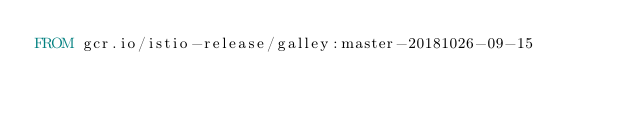<code> <loc_0><loc_0><loc_500><loc_500><_Dockerfile_>FROM gcr.io/istio-release/galley:master-20181026-09-15
</code> 